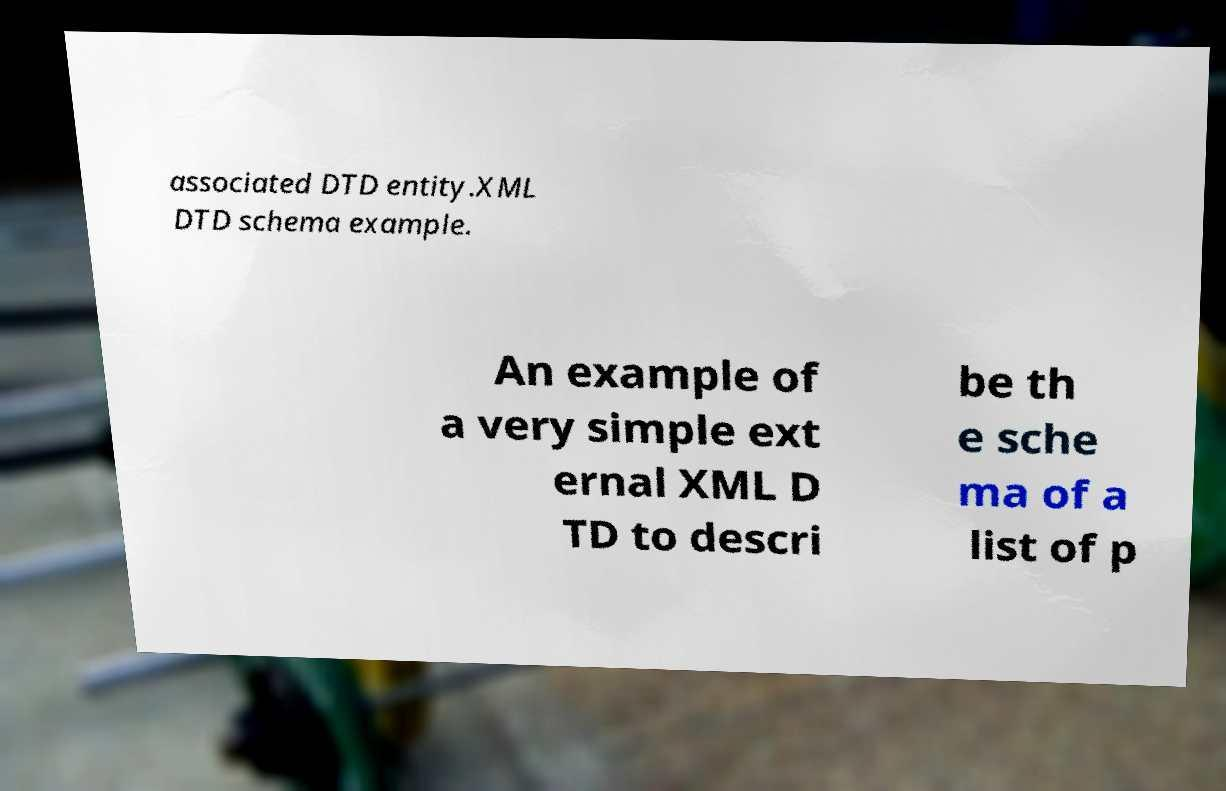Can you read and provide the text displayed in the image?This photo seems to have some interesting text. Can you extract and type it out for me? associated DTD entity.XML DTD schema example. An example of a very simple ext ernal XML D TD to descri be th e sche ma of a list of p 